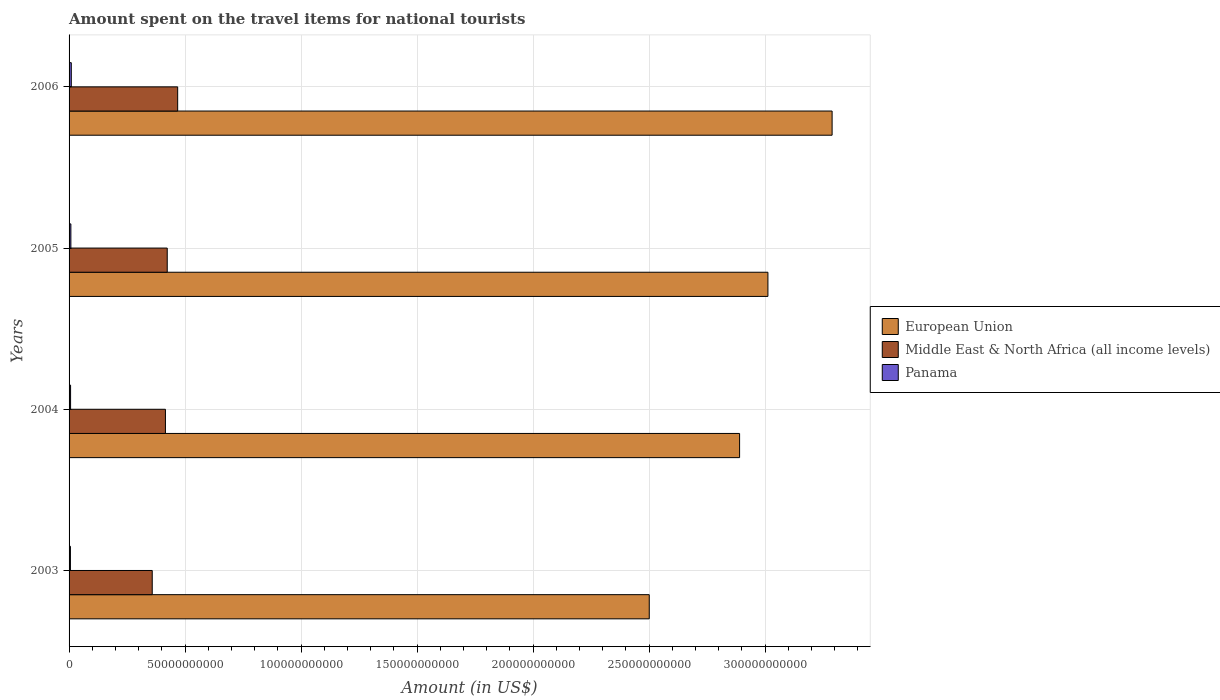How many groups of bars are there?
Your answer should be compact. 4. How many bars are there on the 1st tick from the top?
Your response must be concise. 3. In how many cases, is the number of bars for a given year not equal to the number of legend labels?
Your answer should be very brief. 0. What is the amount spent on the travel items for national tourists in Panama in 2003?
Your answer should be very brief. 5.85e+08. Across all years, what is the maximum amount spent on the travel items for national tourists in Panama?
Keep it short and to the point. 9.60e+08. Across all years, what is the minimum amount spent on the travel items for national tourists in Panama?
Make the answer very short. 5.85e+08. In which year was the amount spent on the travel items for national tourists in European Union maximum?
Offer a very short reply. 2006. In which year was the amount spent on the travel items for national tourists in Middle East & North Africa (all income levels) minimum?
Ensure brevity in your answer.  2003. What is the total amount spent on the travel items for national tourists in Panama in the graph?
Provide a short and direct response. 2.98e+09. What is the difference between the amount spent on the travel items for national tourists in European Union in 2005 and that in 2006?
Offer a terse response. -2.77e+1. What is the difference between the amount spent on the travel items for national tourists in Panama in 2006 and the amount spent on the travel items for national tourists in Middle East & North Africa (all income levels) in 2005?
Provide a succinct answer. -4.13e+1. What is the average amount spent on the travel items for national tourists in European Union per year?
Make the answer very short. 2.92e+11. In the year 2006, what is the difference between the amount spent on the travel items for national tourists in Middle East & North Africa (all income levels) and amount spent on the travel items for national tourists in European Union?
Your answer should be compact. -2.82e+11. In how many years, is the amount spent on the travel items for national tourists in European Union greater than 320000000000 US$?
Offer a terse response. 1. What is the ratio of the amount spent on the travel items for national tourists in Middle East & North Africa (all income levels) in 2003 to that in 2004?
Offer a very short reply. 0.86. Is the amount spent on the travel items for national tourists in European Union in 2003 less than that in 2005?
Offer a very short reply. Yes. What is the difference between the highest and the second highest amount spent on the travel items for national tourists in Middle East & North Africa (all income levels)?
Give a very brief answer. 4.50e+09. What is the difference between the highest and the lowest amount spent on the travel items for national tourists in Panama?
Give a very brief answer. 3.75e+08. In how many years, is the amount spent on the travel items for national tourists in Middle East & North Africa (all income levels) greater than the average amount spent on the travel items for national tourists in Middle East & North Africa (all income levels) taken over all years?
Make the answer very short. 2. Is the sum of the amount spent on the travel items for national tourists in Middle East & North Africa (all income levels) in 2003 and 2006 greater than the maximum amount spent on the travel items for national tourists in European Union across all years?
Offer a terse response. No. What does the 2nd bar from the top in 2005 represents?
Your answer should be very brief. Middle East & North Africa (all income levels). What does the 2nd bar from the bottom in 2003 represents?
Give a very brief answer. Middle East & North Africa (all income levels). How many bars are there?
Offer a terse response. 12. Are all the bars in the graph horizontal?
Your response must be concise. Yes. How many years are there in the graph?
Offer a terse response. 4. Are the values on the major ticks of X-axis written in scientific E-notation?
Ensure brevity in your answer.  No. Where does the legend appear in the graph?
Make the answer very short. Center right. How many legend labels are there?
Offer a terse response. 3. How are the legend labels stacked?
Offer a very short reply. Vertical. What is the title of the graph?
Make the answer very short. Amount spent on the travel items for national tourists. Does "Bhutan" appear as one of the legend labels in the graph?
Provide a short and direct response. No. What is the label or title of the X-axis?
Provide a succinct answer. Amount (in US$). What is the Amount (in US$) of European Union in 2003?
Provide a succinct answer. 2.50e+11. What is the Amount (in US$) of Middle East & North Africa (all income levels) in 2003?
Give a very brief answer. 3.58e+1. What is the Amount (in US$) in Panama in 2003?
Your response must be concise. 5.85e+08. What is the Amount (in US$) of European Union in 2004?
Make the answer very short. 2.89e+11. What is the Amount (in US$) of Middle East & North Africa (all income levels) in 2004?
Your answer should be compact. 4.15e+1. What is the Amount (in US$) in Panama in 2004?
Make the answer very short. 6.51e+08. What is the Amount (in US$) in European Union in 2005?
Your answer should be compact. 3.01e+11. What is the Amount (in US$) in Middle East & North Africa (all income levels) in 2005?
Your answer should be very brief. 4.23e+1. What is the Amount (in US$) of Panama in 2005?
Make the answer very short. 7.80e+08. What is the Amount (in US$) of European Union in 2006?
Your response must be concise. 3.29e+11. What is the Amount (in US$) of Middle East & North Africa (all income levels) in 2006?
Offer a very short reply. 4.68e+1. What is the Amount (in US$) in Panama in 2006?
Provide a succinct answer. 9.60e+08. Across all years, what is the maximum Amount (in US$) of European Union?
Make the answer very short. 3.29e+11. Across all years, what is the maximum Amount (in US$) in Middle East & North Africa (all income levels)?
Keep it short and to the point. 4.68e+1. Across all years, what is the maximum Amount (in US$) in Panama?
Keep it short and to the point. 9.60e+08. Across all years, what is the minimum Amount (in US$) of European Union?
Give a very brief answer. 2.50e+11. Across all years, what is the minimum Amount (in US$) of Middle East & North Africa (all income levels)?
Offer a terse response. 3.58e+1. Across all years, what is the minimum Amount (in US$) of Panama?
Your answer should be very brief. 5.85e+08. What is the total Amount (in US$) in European Union in the graph?
Offer a terse response. 1.17e+12. What is the total Amount (in US$) in Middle East & North Africa (all income levels) in the graph?
Your response must be concise. 1.66e+11. What is the total Amount (in US$) in Panama in the graph?
Your answer should be very brief. 2.98e+09. What is the difference between the Amount (in US$) of European Union in 2003 and that in 2004?
Ensure brevity in your answer.  -3.89e+1. What is the difference between the Amount (in US$) of Middle East & North Africa (all income levels) in 2003 and that in 2004?
Ensure brevity in your answer.  -5.69e+09. What is the difference between the Amount (in US$) of Panama in 2003 and that in 2004?
Keep it short and to the point. -6.60e+07. What is the difference between the Amount (in US$) in European Union in 2003 and that in 2005?
Offer a very short reply. -5.11e+1. What is the difference between the Amount (in US$) of Middle East & North Africa (all income levels) in 2003 and that in 2005?
Your answer should be very brief. -6.47e+09. What is the difference between the Amount (in US$) in Panama in 2003 and that in 2005?
Ensure brevity in your answer.  -1.95e+08. What is the difference between the Amount (in US$) of European Union in 2003 and that in 2006?
Offer a very short reply. -7.88e+1. What is the difference between the Amount (in US$) in Middle East & North Africa (all income levels) in 2003 and that in 2006?
Offer a terse response. -1.10e+1. What is the difference between the Amount (in US$) of Panama in 2003 and that in 2006?
Keep it short and to the point. -3.75e+08. What is the difference between the Amount (in US$) of European Union in 2004 and that in 2005?
Offer a very short reply. -1.22e+1. What is the difference between the Amount (in US$) in Middle East & North Africa (all income levels) in 2004 and that in 2005?
Offer a terse response. -7.77e+08. What is the difference between the Amount (in US$) of Panama in 2004 and that in 2005?
Your response must be concise. -1.29e+08. What is the difference between the Amount (in US$) of European Union in 2004 and that in 2006?
Your answer should be very brief. -3.99e+1. What is the difference between the Amount (in US$) in Middle East & North Africa (all income levels) in 2004 and that in 2006?
Offer a terse response. -5.27e+09. What is the difference between the Amount (in US$) of Panama in 2004 and that in 2006?
Give a very brief answer. -3.09e+08. What is the difference between the Amount (in US$) in European Union in 2005 and that in 2006?
Ensure brevity in your answer.  -2.77e+1. What is the difference between the Amount (in US$) in Middle East & North Africa (all income levels) in 2005 and that in 2006?
Provide a succinct answer. -4.50e+09. What is the difference between the Amount (in US$) in Panama in 2005 and that in 2006?
Keep it short and to the point. -1.80e+08. What is the difference between the Amount (in US$) of European Union in 2003 and the Amount (in US$) of Middle East & North Africa (all income levels) in 2004?
Make the answer very short. 2.09e+11. What is the difference between the Amount (in US$) of European Union in 2003 and the Amount (in US$) of Panama in 2004?
Provide a short and direct response. 2.49e+11. What is the difference between the Amount (in US$) in Middle East & North Africa (all income levels) in 2003 and the Amount (in US$) in Panama in 2004?
Your answer should be very brief. 3.52e+1. What is the difference between the Amount (in US$) of European Union in 2003 and the Amount (in US$) of Middle East & North Africa (all income levels) in 2005?
Your response must be concise. 2.08e+11. What is the difference between the Amount (in US$) of European Union in 2003 and the Amount (in US$) of Panama in 2005?
Offer a very short reply. 2.49e+11. What is the difference between the Amount (in US$) in Middle East & North Africa (all income levels) in 2003 and the Amount (in US$) in Panama in 2005?
Your answer should be very brief. 3.51e+1. What is the difference between the Amount (in US$) of European Union in 2003 and the Amount (in US$) of Middle East & North Africa (all income levels) in 2006?
Your response must be concise. 2.03e+11. What is the difference between the Amount (in US$) of European Union in 2003 and the Amount (in US$) of Panama in 2006?
Give a very brief answer. 2.49e+11. What is the difference between the Amount (in US$) in Middle East & North Africa (all income levels) in 2003 and the Amount (in US$) in Panama in 2006?
Your answer should be compact. 3.49e+1. What is the difference between the Amount (in US$) in European Union in 2004 and the Amount (in US$) in Middle East & North Africa (all income levels) in 2005?
Offer a terse response. 2.47e+11. What is the difference between the Amount (in US$) in European Union in 2004 and the Amount (in US$) in Panama in 2005?
Your answer should be compact. 2.88e+11. What is the difference between the Amount (in US$) in Middle East & North Africa (all income levels) in 2004 and the Amount (in US$) in Panama in 2005?
Offer a very short reply. 4.07e+1. What is the difference between the Amount (in US$) in European Union in 2004 and the Amount (in US$) in Middle East & North Africa (all income levels) in 2006?
Give a very brief answer. 2.42e+11. What is the difference between the Amount (in US$) of European Union in 2004 and the Amount (in US$) of Panama in 2006?
Provide a succinct answer. 2.88e+11. What is the difference between the Amount (in US$) of Middle East & North Africa (all income levels) in 2004 and the Amount (in US$) of Panama in 2006?
Make the answer very short. 4.06e+1. What is the difference between the Amount (in US$) in European Union in 2005 and the Amount (in US$) in Middle East & North Africa (all income levels) in 2006?
Offer a terse response. 2.54e+11. What is the difference between the Amount (in US$) of European Union in 2005 and the Amount (in US$) of Panama in 2006?
Ensure brevity in your answer.  3.00e+11. What is the difference between the Amount (in US$) in Middle East & North Africa (all income levels) in 2005 and the Amount (in US$) in Panama in 2006?
Keep it short and to the point. 4.13e+1. What is the average Amount (in US$) of European Union per year?
Make the answer very short. 2.92e+11. What is the average Amount (in US$) of Middle East & North Africa (all income levels) per year?
Your response must be concise. 4.16e+1. What is the average Amount (in US$) of Panama per year?
Provide a succinct answer. 7.44e+08. In the year 2003, what is the difference between the Amount (in US$) of European Union and Amount (in US$) of Middle East & North Africa (all income levels)?
Make the answer very short. 2.14e+11. In the year 2003, what is the difference between the Amount (in US$) in European Union and Amount (in US$) in Panama?
Offer a terse response. 2.49e+11. In the year 2003, what is the difference between the Amount (in US$) in Middle East & North Africa (all income levels) and Amount (in US$) in Panama?
Provide a succinct answer. 3.53e+1. In the year 2004, what is the difference between the Amount (in US$) in European Union and Amount (in US$) in Middle East & North Africa (all income levels)?
Offer a terse response. 2.47e+11. In the year 2004, what is the difference between the Amount (in US$) in European Union and Amount (in US$) in Panama?
Your answer should be very brief. 2.88e+11. In the year 2004, what is the difference between the Amount (in US$) in Middle East & North Africa (all income levels) and Amount (in US$) in Panama?
Your answer should be compact. 4.09e+1. In the year 2005, what is the difference between the Amount (in US$) of European Union and Amount (in US$) of Middle East & North Africa (all income levels)?
Your answer should be very brief. 2.59e+11. In the year 2005, what is the difference between the Amount (in US$) of European Union and Amount (in US$) of Panama?
Keep it short and to the point. 3.00e+11. In the year 2005, what is the difference between the Amount (in US$) of Middle East & North Africa (all income levels) and Amount (in US$) of Panama?
Ensure brevity in your answer.  4.15e+1. In the year 2006, what is the difference between the Amount (in US$) in European Union and Amount (in US$) in Middle East & North Africa (all income levels)?
Your answer should be compact. 2.82e+11. In the year 2006, what is the difference between the Amount (in US$) in European Union and Amount (in US$) in Panama?
Keep it short and to the point. 3.28e+11. In the year 2006, what is the difference between the Amount (in US$) in Middle East & North Africa (all income levels) and Amount (in US$) in Panama?
Make the answer very short. 4.58e+1. What is the ratio of the Amount (in US$) in European Union in 2003 to that in 2004?
Your answer should be very brief. 0.87. What is the ratio of the Amount (in US$) in Middle East & North Africa (all income levels) in 2003 to that in 2004?
Give a very brief answer. 0.86. What is the ratio of the Amount (in US$) of Panama in 2003 to that in 2004?
Your answer should be very brief. 0.9. What is the ratio of the Amount (in US$) in European Union in 2003 to that in 2005?
Provide a succinct answer. 0.83. What is the ratio of the Amount (in US$) in Middle East & North Africa (all income levels) in 2003 to that in 2005?
Ensure brevity in your answer.  0.85. What is the ratio of the Amount (in US$) in European Union in 2003 to that in 2006?
Offer a terse response. 0.76. What is the ratio of the Amount (in US$) of Middle East & North Africa (all income levels) in 2003 to that in 2006?
Ensure brevity in your answer.  0.77. What is the ratio of the Amount (in US$) of Panama in 2003 to that in 2006?
Make the answer very short. 0.61. What is the ratio of the Amount (in US$) of European Union in 2004 to that in 2005?
Your response must be concise. 0.96. What is the ratio of the Amount (in US$) in Middle East & North Africa (all income levels) in 2004 to that in 2005?
Your answer should be very brief. 0.98. What is the ratio of the Amount (in US$) in Panama in 2004 to that in 2005?
Provide a succinct answer. 0.83. What is the ratio of the Amount (in US$) in European Union in 2004 to that in 2006?
Your response must be concise. 0.88. What is the ratio of the Amount (in US$) of Middle East & North Africa (all income levels) in 2004 to that in 2006?
Your answer should be very brief. 0.89. What is the ratio of the Amount (in US$) in Panama in 2004 to that in 2006?
Give a very brief answer. 0.68. What is the ratio of the Amount (in US$) of European Union in 2005 to that in 2006?
Offer a very short reply. 0.92. What is the ratio of the Amount (in US$) in Middle East & North Africa (all income levels) in 2005 to that in 2006?
Make the answer very short. 0.9. What is the ratio of the Amount (in US$) in Panama in 2005 to that in 2006?
Ensure brevity in your answer.  0.81. What is the difference between the highest and the second highest Amount (in US$) of European Union?
Your response must be concise. 2.77e+1. What is the difference between the highest and the second highest Amount (in US$) of Middle East & North Africa (all income levels)?
Offer a terse response. 4.50e+09. What is the difference between the highest and the second highest Amount (in US$) in Panama?
Ensure brevity in your answer.  1.80e+08. What is the difference between the highest and the lowest Amount (in US$) of European Union?
Provide a short and direct response. 7.88e+1. What is the difference between the highest and the lowest Amount (in US$) in Middle East & North Africa (all income levels)?
Your answer should be compact. 1.10e+1. What is the difference between the highest and the lowest Amount (in US$) in Panama?
Your answer should be very brief. 3.75e+08. 